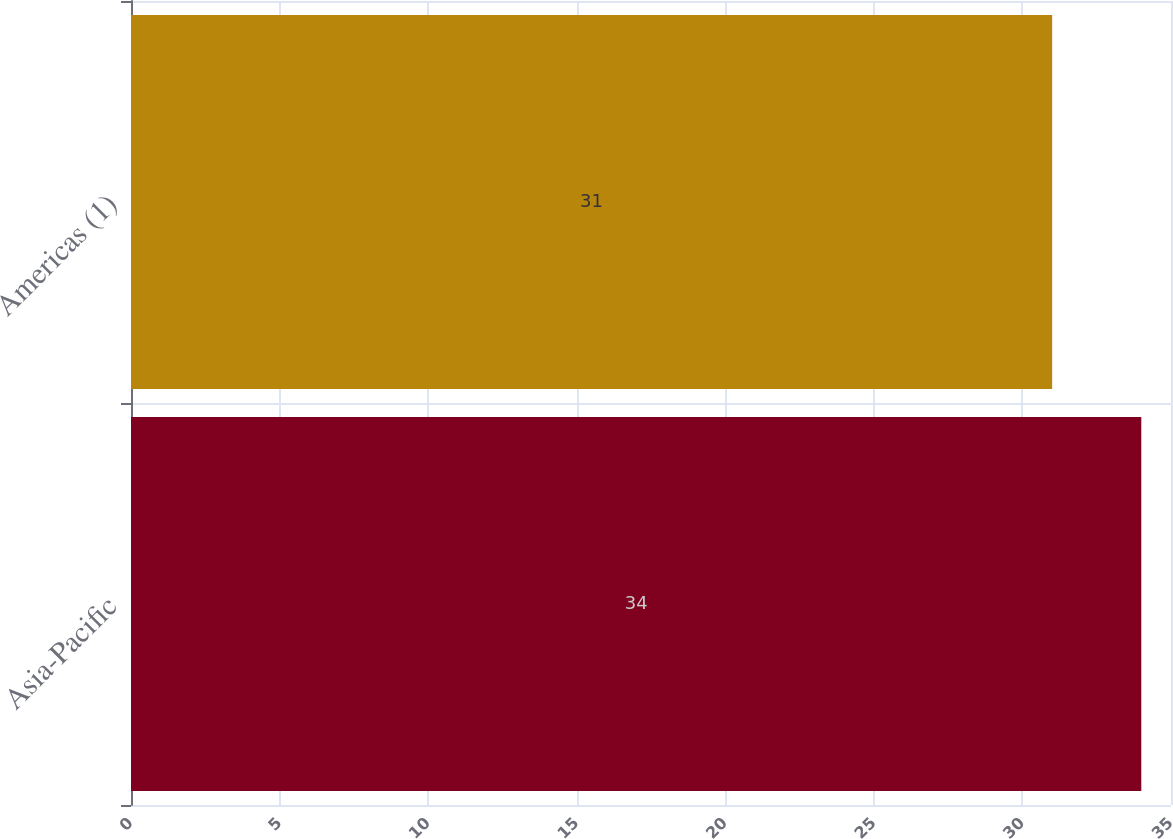Convert chart. <chart><loc_0><loc_0><loc_500><loc_500><bar_chart><fcel>Asia-Pacific<fcel>Americas (1)<nl><fcel>34<fcel>31<nl></chart> 